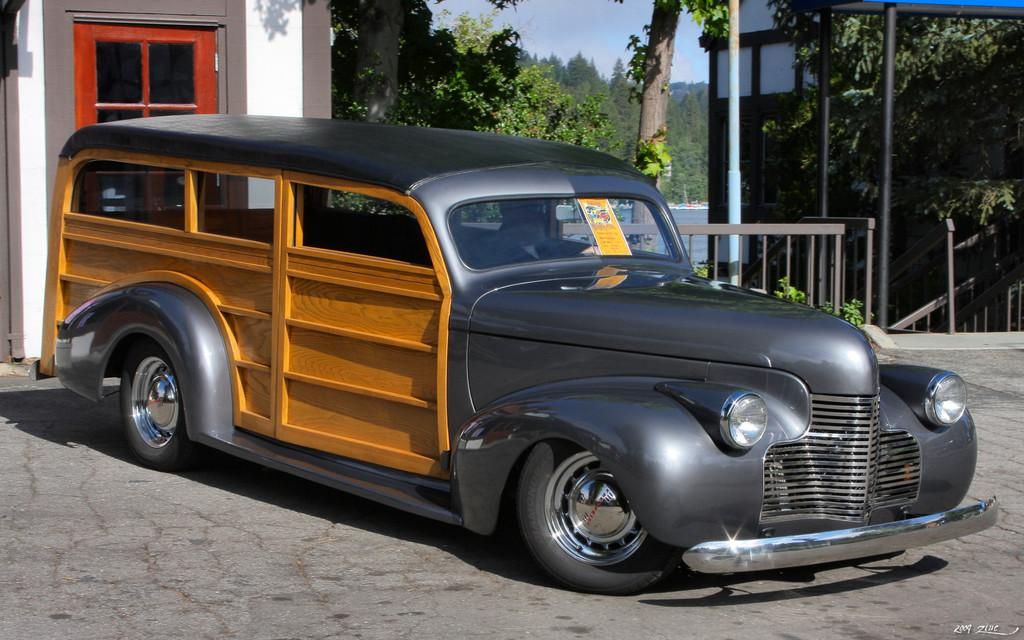What is the main subject of the image? There is a vehicle on the road in the image. What can be seen in the background of the image? There is a railing, buildings, trees, and water visible in the background of the image. How many types of vegetation can be seen in the image? There are trees visible in the image, both in the background and foreground. What part of the natural environment is visible in the image? The sky is visible in the image. What type of interest can be heard in the image? There is no audible information in the image, so it is not possible to determine any interest or sound. 